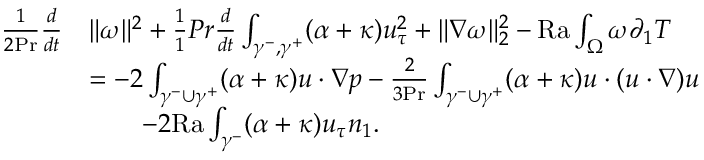<formula> <loc_0><loc_0><loc_500><loc_500>\begin{array} { r l } { \frac { 1 } { 2 P r } \frac { d } { d t } } & { \| \omega \| ^ { 2 } + \frac { 1 } { 1 } { P r } \frac { d } { d t } \int _ { \gamma ^ { - } , \gamma ^ { + } } ( \alpha + \kappa ) u _ { \tau } ^ { 2 } + \| \nabla \omega \| _ { 2 } ^ { 2 } - { R a } \int _ { \Omega } \omega \partial _ { 1 } T } \\ & { = - 2 \int _ { \gamma ^ { - } \cup \gamma ^ { + } } ( \alpha + \kappa ) u \cdot \nabla p - \frac { 2 } { 3 P r } \int _ { \gamma ^ { - } \cup \gamma ^ { + } } ( \alpha + \kappa ) u \cdot ( u \cdot \nabla ) u } \\ & { \quad - 2 { R a } \int _ { \gamma ^ { - } } ( \alpha + \kappa ) u _ { \tau } n _ { 1 } . } \end{array}</formula> 